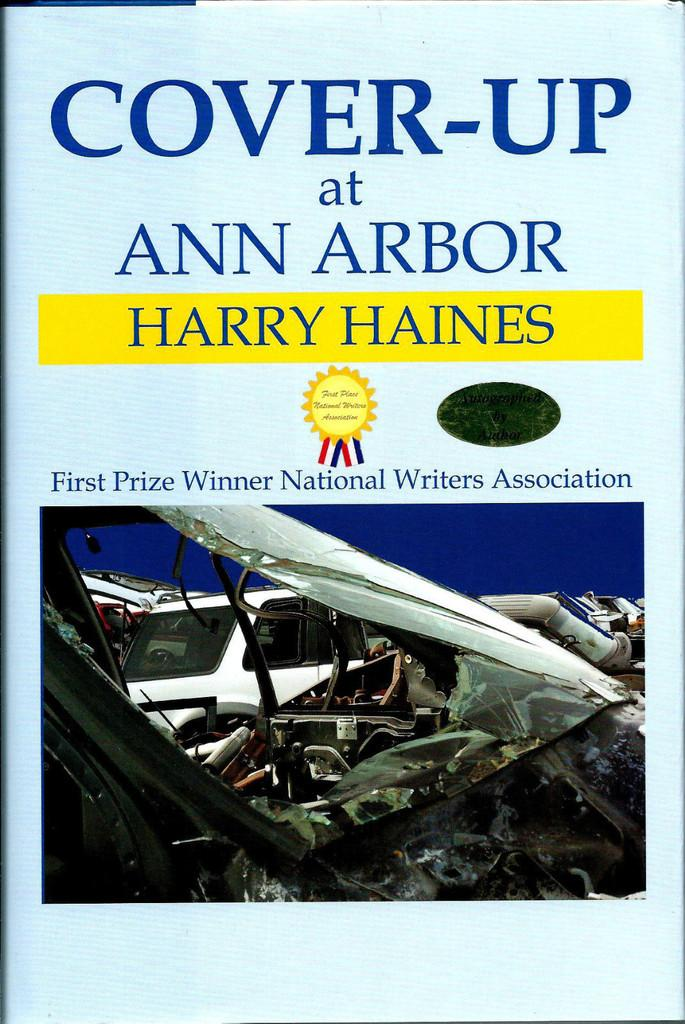<image>
Summarize the visual content of the image. Book cover of a book by Harry Haines. 